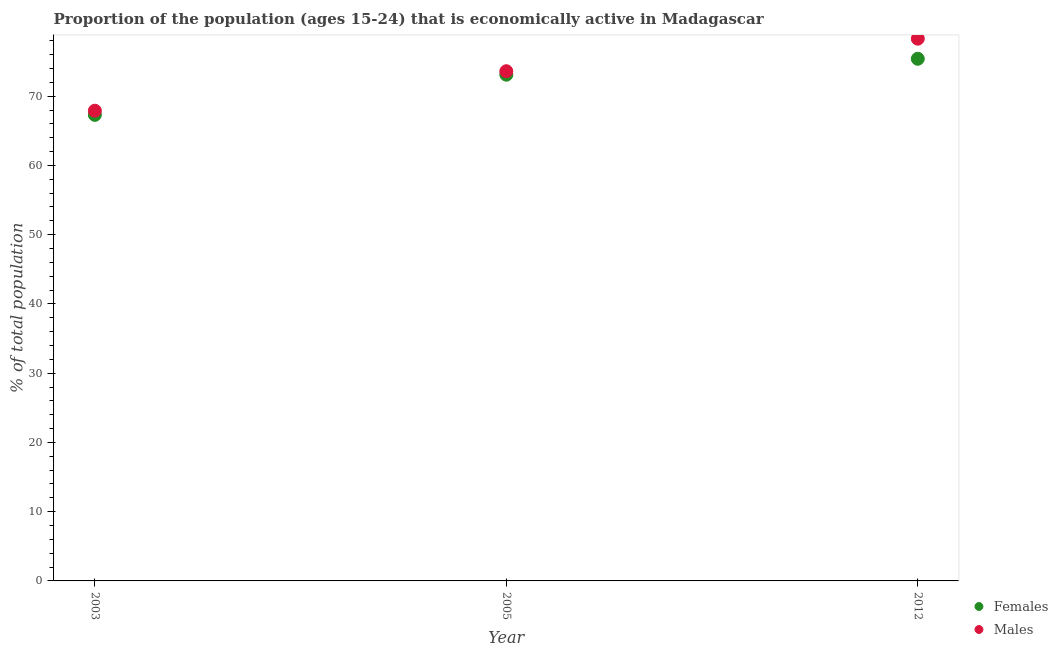Is the number of dotlines equal to the number of legend labels?
Offer a very short reply. Yes. What is the percentage of economically active male population in 2003?
Ensure brevity in your answer.  67.9. Across all years, what is the maximum percentage of economically active female population?
Keep it short and to the point. 75.4. Across all years, what is the minimum percentage of economically active female population?
Your answer should be compact. 67.3. In which year was the percentage of economically active male population minimum?
Offer a terse response. 2003. What is the total percentage of economically active female population in the graph?
Provide a succinct answer. 215.8. What is the difference between the percentage of economically active female population in 2003 and that in 2005?
Provide a short and direct response. -5.8. What is the difference between the percentage of economically active male population in 2003 and the percentage of economically active female population in 2005?
Offer a very short reply. -5.2. What is the average percentage of economically active female population per year?
Your response must be concise. 71.93. In the year 2003, what is the difference between the percentage of economically active female population and percentage of economically active male population?
Your response must be concise. -0.6. In how many years, is the percentage of economically active male population greater than 28 %?
Your answer should be compact. 3. What is the ratio of the percentage of economically active male population in 2003 to that in 2005?
Your answer should be very brief. 0.92. Is the percentage of economically active male population in 2005 less than that in 2012?
Keep it short and to the point. Yes. Is the difference between the percentage of economically active male population in 2003 and 2005 greater than the difference between the percentage of economically active female population in 2003 and 2005?
Make the answer very short. Yes. What is the difference between the highest and the second highest percentage of economically active female population?
Provide a short and direct response. 2.3. What is the difference between the highest and the lowest percentage of economically active male population?
Ensure brevity in your answer.  10.4. Does the percentage of economically active female population monotonically increase over the years?
Provide a short and direct response. Yes. Is the percentage of economically active female population strictly greater than the percentage of economically active male population over the years?
Provide a short and direct response. No. Is the percentage of economically active female population strictly less than the percentage of economically active male population over the years?
Your answer should be compact. Yes. What is the difference between two consecutive major ticks on the Y-axis?
Keep it short and to the point. 10. Are the values on the major ticks of Y-axis written in scientific E-notation?
Provide a short and direct response. No. Does the graph contain any zero values?
Offer a very short reply. No. Does the graph contain grids?
Provide a short and direct response. No. Where does the legend appear in the graph?
Ensure brevity in your answer.  Bottom right. How many legend labels are there?
Offer a terse response. 2. How are the legend labels stacked?
Ensure brevity in your answer.  Vertical. What is the title of the graph?
Make the answer very short. Proportion of the population (ages 15-24) that is economically active in Madagascar. What is the label or title of the X-axis?
Offer a very short reply. Year. What is the label or title of the Y-axis?
Offer a very short reply. % of total population. What is the % of total population of Females in 2003?
Give a very brief answer. 67.3. What is the % of total population in Males in 2003?
Keep it short and to the point. 67.9. What is the % of total population of Females in 2005?
Your answer should be very brief. 73.1. What is the % of total population of Males in 2005?
Your response must be concise. 73.6. What is the % of total population in Females in 2012?
Provide a short and direct response. 75.4. What is the % of total population of Males in 2012?
Provide a short and direct response. 78.3. Across all years, what is the maximum % of total population of Females?
Give a very brief answer. 75.4. Across all years, what is the maximum % of total population of Males?
Your response must be concise. 78.3. Across all years, what is the minimum % of total population of Females?
Offer a very short reply. 67.3. Across all years, what is the minimum % of total population in Males?
Offer a terse response. 67.9. What is the total % of total population in Females in the graph?
Your answer should be compact. 215.8. What is the total % of total population in Males in the graph?
Give a very brief answer. 219.8. What is the difference between the % of total population of Females in 2003 and that in 2005?
Your answer should be very brief. -5.8. What is the difference between the % of total population in Females in 2003 and that in 2012?
Your response must be concise. -8.1. What is the difference between the % of total population in Females in 2005 and that in 2012?
Your response must be concise. -2.3. What is the difference between the % of total population of Males in 2005 and that in 2012?
Provide a short and direct response. -4.7. What is the difference between the % of total population of Females in 2003 and the % of total population of Males in 2005?
Your response must be concise. -6.3. What is the difference between the % of total population in Females in 2003 and the % of total population in Males in 2012?
Ensure brevity in your answer.  -11. What is the average % of total population in Females per year?
Offer a very short reply. 71.93. What is the average % of total population of Males per year?
Offer a very short reply. 73.27. In the year 2003, what is the difference between the % of total population of Females and % of total population of Males?
Keep it short and to the point. -0.6. In the year 2012, what is the difference between the % of total population of Females and % of total population of Males?
Keep it short and to the point. -2.9. What is the ratio of the % of total population in Females in 2003 to that in 2005?
Provide a succinct answer. 0.92. What is the ratio of the % of total population in Males in 2003 to that in 2005?
Ensure brevity in your answer.  0.92. What is the ratio of the % of total population of Females in 2003 to that in 2012?
Offer a terse response. 0.89. What is the ratio of the % of total population in Males in 2003 to that in 2012?
Ensure brevity in your answer.  0.87. What is the ratio of the % of total population of Females in 2005 to that in 2012?
Offer a very short reply. 0.97. What is the ratio of the % of total population in Males in 2005 to that in 2012?
Ensure brevity in your answer.  0.94. What is the difference between the highest and the second highest % of total population in Females?
Offer a very short reply. 2.3. What is the difference between the highest and the lowest % of total population in Females?
Keep it short and to the point. 8.1. 